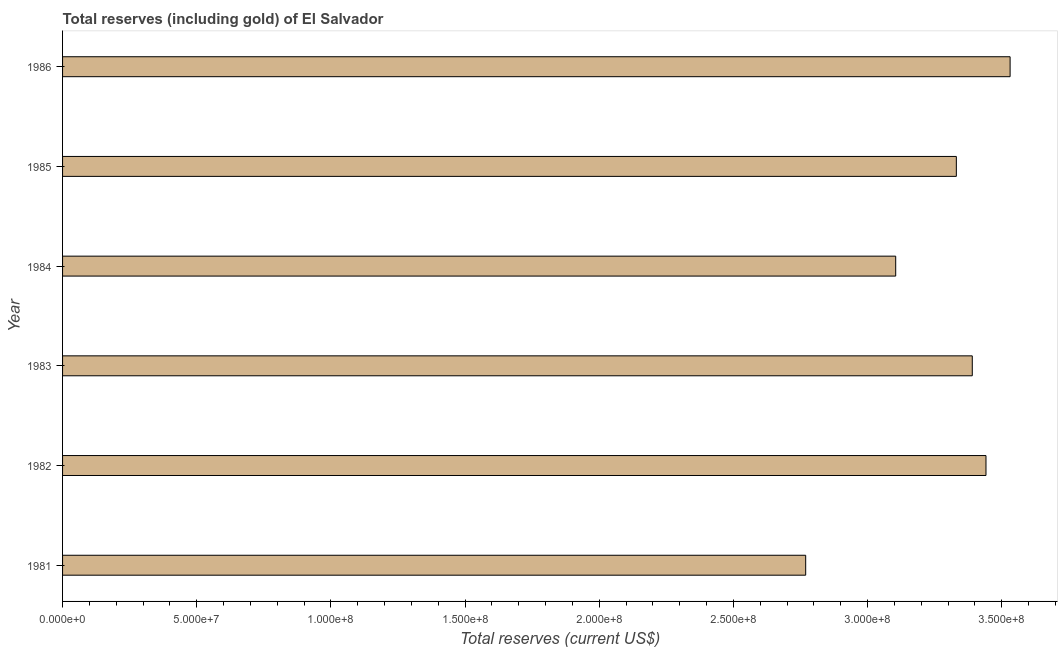What is the title of the graph?
Your response must be concise. Total reserves (including gold) of El Salvador. What is the label or title of the X-axis?
Your answer should be compact. Total reserves (current US$). What is the label or title of the Y-axis?
Provide a short and direct response. Year. What is the total reserves (including gold) in 1986?
Provide a succinct answer. 3.53e+08. Across all years, what is the maximum total reserves (including gold)?
Give a very brief answer. 3.53e+08. Across all years, what is the minimum total reserves (including gold)?
Your answer should be very brief. 2.77e+08. What is the sum of the total reserves (including gold)?
Make the answer very short. 1.96e+09. What is the difference between the total reserves (including gold) in 1983 and 1985?
Offer a very short reply. 5.94e+06. What is the average total reserves (including gold) per year?
Keep it short and to the point. 3.26e+08. What is the median total reserves (including gold)?
Give a very brief answer. 3.36e+08. Do a majority of the years between 1984 and 1981 (inclusive) have total reserves (including gold) greater than 350000000 US$?
Offer a very short reply. Yes. What is the ratio of the total reserves (including gold) in 1982 to that in 1985?
Offer a terse response. 1.03. What is the difference between the highest and the second highest total reserves (including gold)?
Your answer should be very brief. 8.99e+06. What is the difference between the highest and the lowest total reserves (including gold)?
Your answer should be very brief. 7.62e+07. In how many years, is the total reserves (including gold) greater than the average total reserves (including gold) taken over all years?
Offer a terse response. 4. Are all the bars in the graph horizontal?
Your answer should be very brief. Yes. How many years are there in the graph?
Give a very brief answer. 6. What is the difference between two consecutive major ticks on the X-axis?
Offer a very short reply. 5.00e+07. Are the values on the major ticks of X-axis written in scientific E-notation?
Your response must be concise. Yes. What is the Total reserves (current US$) of 1981?
Offer a terse response. 2.77e+08. What is the Total reserves (current US$) in 1982?
Ensure brevity in your answer.  3.44e+08. What is the Total reserves (current US$) of 1983?
Ensure brevity in your answer.  3.39e+08. What is the Total reserves (current US$) of 1984?
Provide a short and direct response. 3.10e+08. What is the Total reserves (current US$) in 1985?
Give a very brief answer. 3.33e+08. What is the Total reserves (current US$) in 1986?
Ensure brevity in your answer.  3.53e+08. What is the difference between the Total reserves (current US$) in 1981 and 1982?
Your response must be concise. -6.72e+07. What is the difference between the Total reserves (current US$) in 1981 and 1983?
Make the answer very short. -6.21e+07. What is the difference between the Total reserves (current US$) in 1981 and 1984?
Make the answer very short. -3.35e+07. What is the difference between the Total reserves (current US$) in 1981 and 1985?
Provide a short and direct response. -5.61e+07. What is the difference between the Total reserves (current US$) in 1981 and 1986?
Ensure brevity in your answer.  -7.62e+07. What is the difference between the Total reserves (current US$) in 1982 and 1983?
Ensure brevity in your answer.  5.11e+06. What is the difference between the Total reserves (current US$) in 1982 and 1984?
Your answer should be very brief. 3.36e+07. What is the difference between the Total reserves (current US$) in 1982 and 1985?
Your answer should be compact. 1.10e+07. What is the difference between the Total reserves (current US$) in 1982 and 1986?
Provide a short and direct response. -8.99e+06. What is the difference between the Total reserves (current US$) in 1983 and 1984?
Offer a terse response. 2.85e+07. What is the difference between the Total reserves (current US$) in 1983 and 1985?
Your answer should be very brief. 5.94e+06. What is the difference between the Total reserves (current US$) in 1983 and 1986?
Your response must be concise. -1.41e+07. What is the difference between the Total reserves (current US$) in 1984 and 1985?
Your answer should be compact. -2.26e+07. What is the difference between the Total reserves (current US$) in 1984 and 1986?
Keep it short and to the point. -4.26e+07. What is the difference between the Total reserves (current US$) in 1985 and 1986?
Keep it short and to the point. -2.00e+07. What is the ratio of the Total reserves (current US$) in 1981 to that in 1982?
Keep it short and to the point. 0.81. What is the ratio of the Total reserves (current US$) in 1981 to that in 1983?
Make the answer very short. 0.82. What is the ratio of the Total reserves (current US$) in 1981 to that in 1984?
Offer a terse response. 0.89. What is the ratio of the Total reserves (current US$) in 1981 to that in 1985?
Make the answer very short. 0.83. What is the ratio of the Total reserves (current US$) in 1981 to that in 1986?
Ensure brevity in your answer.  0.78. What is the ratio of the Total reserves (current US$) in 1982 to that in 1984?
Your answer should be very brief. 1.11. What is the ratio of the Total reserves (current US$) in 1982 to that in 1985?
Your response must be concise. 1.03. What is the ratio of the Total reserves (current US$) in 1982 to that in 1986?
Provide a short and direct response. 0.97. What is the ratio of the Total reserves (current US$) in 1983 to that in 1984?
Your response must be concise. 1.09. What is the ratio of the Total reserves (current US$) in 1983 to that in 1985?
Keep it short and to the point. 1.02. What is the ratio of the Total reserves (current US$) in 1983 to that in 1986?
Keep it short and to the point. 0.96. What is the ratio of the Total reserves (current US$) in 1984 to that in 1985?
Offer a very short reply. 0.93. What is the ratio of the Total reserves (current US$) in 1984 to that in 1986?
Your answer should be very brief. 0.88. What is the ratio of the Total reserves (current US$) in 1985 to that in 1986?
Your answer should be compact. 0.94. 